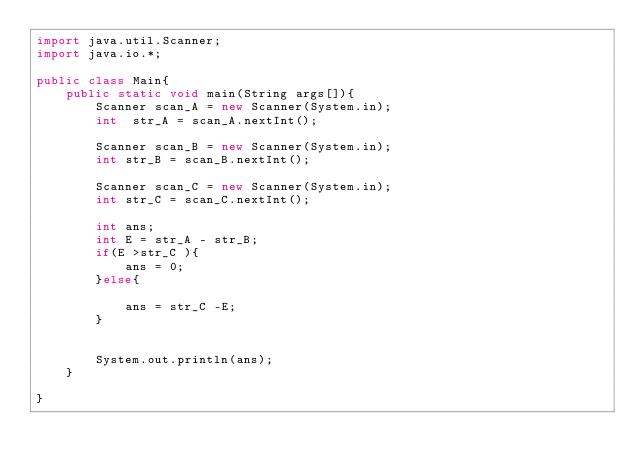<code> <loc_0><loc_0><loc_500><loc_500><_Java_>import java.util.Scanner;
import java.io.*;

public class Main{
    public static void main(String args[]){
        Scanner scan_A = new Scanner(System.in);
        int  str_A = scan_A.nextInt();

        Scanner scan_B = new Scanner(System.in);
        int str_B = scan_B.nextInt();

        Scanner scan_C = new Scanner(System.in);
        int str_C = scan_C.nextInt();

        int ans;
        int E = str_A - str_B;
        if(E >str_C ){
            ans = 0;
        }else{
           
            ans = str_C -E;
        }
       
               
        System.out.println(ans);
    }

}</code> 